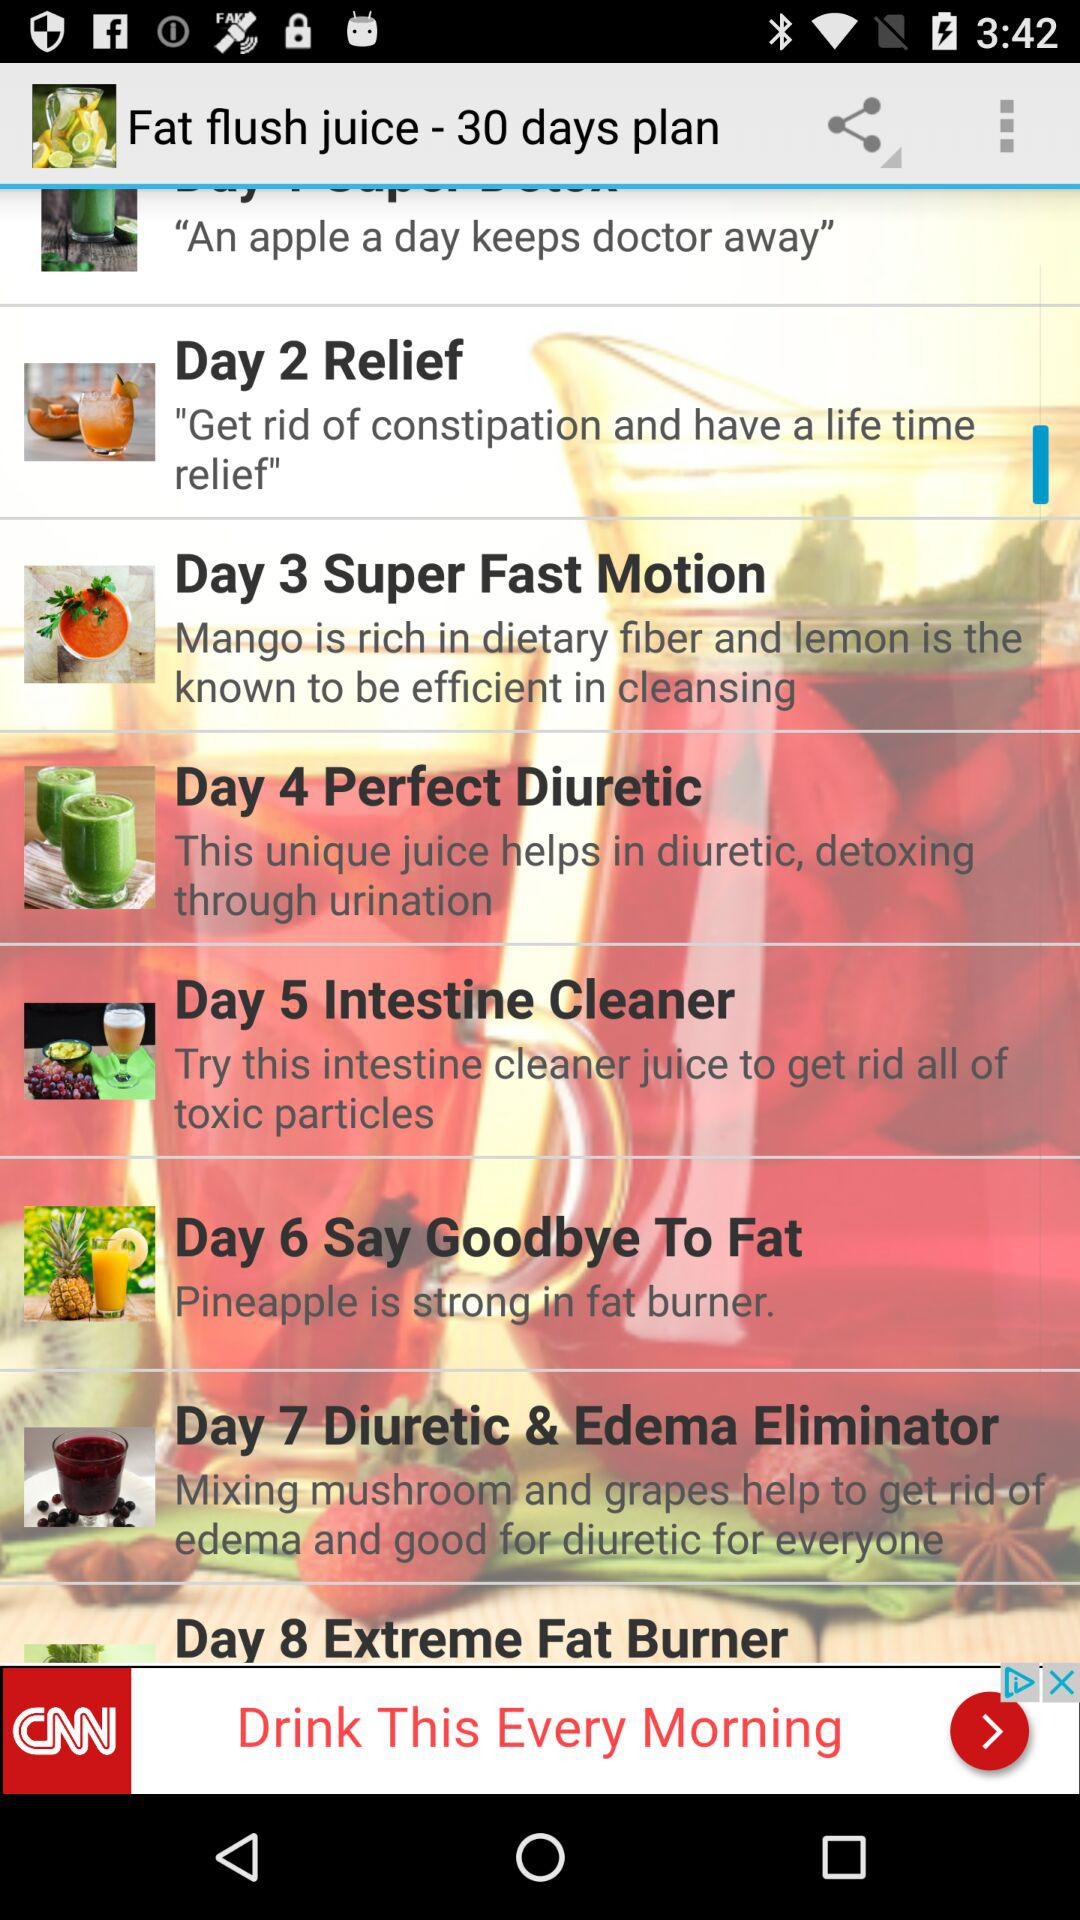Which juice do we have for day 7? The juice we have for day 7 is "Diuretic & Edema Eliminator". 